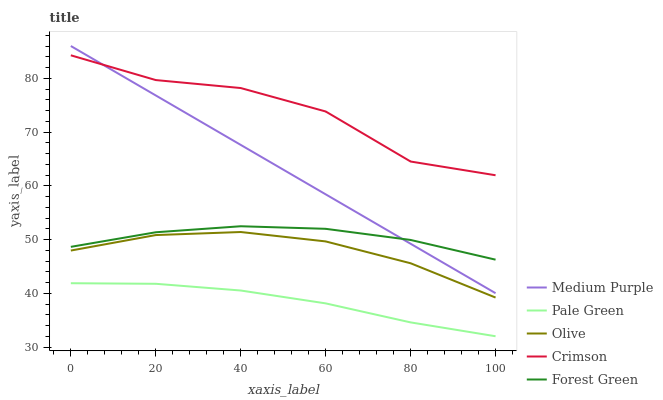Does Pale Green have the minimum area under the curve?
Answer yes or no. Yes. Does Crimson have the maximum area under the curve?
Answer yes or no. Yes. Does Olive have the minimum area under the curve?
Answer yes or no. No. Does Olive have the maximum area under the curve?
Answer yes or no. No. Is Medium Purple the smoothest?
Answer yes or no. Yes. Is Crimson the roughest?
Answer yes or no. Yes. Is Olive the smoothest?
Answer yes or no. No. Is Olive the roughest?
Answer yes or no. No. Does Olive have the lowest value?
Answer yes or no. No. Does Olive have the highest value?
Answer yes or no. No. Is Forest Green less than Crimson?
Answer yes or no. Yes. Is Medium Purple greater than Pale Green?
Answer yes or no. Yes. Does Forest Green intersect Crimson?
Answer yes or no. No. 